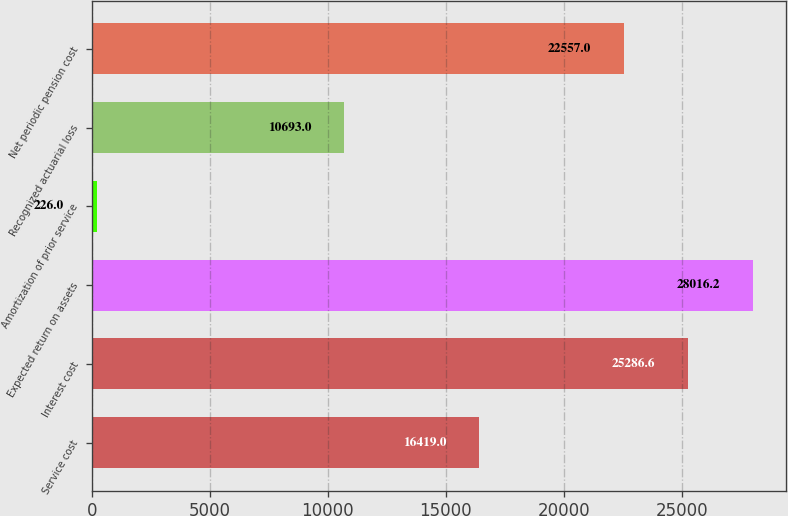Convert chart to OTSL. <chart><loc_0><loc_0><loc_500><loc_500><bar_chart><fcel>Service cost<fcel>Interest cost<fcel>Expected return on assets<fcel>Amortization of prior service<fcel>Recognized actuarial loss<fcel>Net periodic pension cost<nl><fcel>16419<fcel>25286.6<fcel>28016.2<fcel>226<fcel>10693<fcel>22557<nl></chart> 